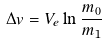<formula> <loc_0><loc_0><loc_500><loc_500>\Delta v = V _ { e } \ln \frac { m _ { 0 } } { m _ { 1 } }</formula> 